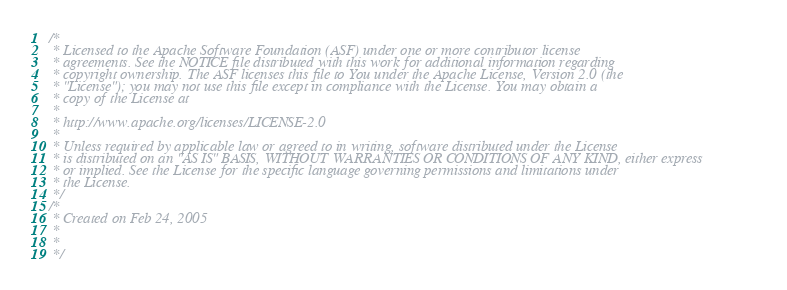<code> <loc_0><loc_0><loc_500><loc_500><_Java_>/*
 * Licensed to the Apache Software Foundation (ASF) under one or more contributor license
 * agreements. See the NOTICE file distributed with this work for additional information regarding
 * copyright ownership. The ASF licenses this file to You under the Apache License, Version 2.0 (the
 * "License"); you may not use this file except in compliance with the License. You may obtain a
 * copy of the License at
 *
 * http://www.apache.org/licenses/LICENSE-2.0
 *
 * Unless required by applicable law or agreed to in writing, software distributed under the License
 * is distributed on an "AS IS" BASIS, WITHOUT WARRANTIES OR CONDITIONS OF ANY KIND, either express
 * or implied. See the License for the specific language governing permissions and limitations under
 * the License.
 */
/*
 * Created on Feb 24, 2005
 *
 *
 */</code> 